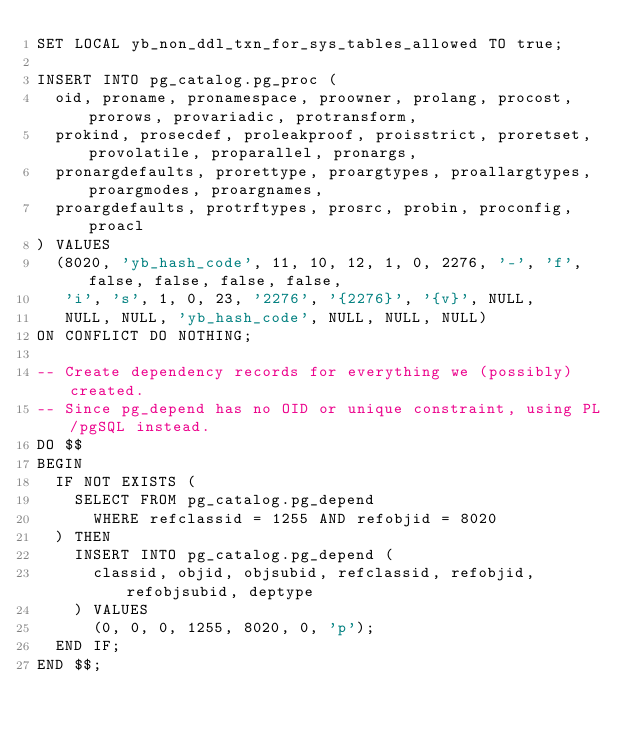<code> <loc_0><loc_0><loc_500><loc_500><_SQL_>SET LOCAL yb_non_ddl_txn_for_sys_tables_allowed TO true;

INSERT INTO pg_catalog.pg_proc (
  oid, proname, pronamespace, proowner, prolang, procost, prorows, provariadic, protransform,
  prokind, prosecdef, proleakproof, proisstrict, proretset, provolatile, proparallel, pronargs,
  pronargdefaults, prorettype, proargtypes, proallargtypes, proargmodes, proargnames,
  proargdefaults, protrftypes, prosrc, probin, proconfig, proacl
) VALUES
  (8020, 'yb_hash_code', 11, 10, 12, 1, 0, 2276, '-', 'f', false, false, false, false,
   'i', 's', 1, 0, 23, '2276', '{2276}', '{v}', NULL,
   NULL, NULL, 'yb_hash_code', NULL, NULL, NULL)
ON CONFLICT DO NOTHING;

-- Create dependency records for everything we (possibly) created.
-- Since pg_depend has no OID or unique constraint, using PL/pgSQL instead.
DO $$
BEGIN
  IF NOT EXISTS (
    SELECT FROM pg_catalog.pg_depend
      WHERE refclassid = 1255 AND refobjid = 8020
  ) THEN
    INSERT INTO pg_catalog.pg_depend (
      classid, objid, objsubid, refclassid, refobjid, refobjsubid, deptype
    ) VALUES
      (0, 0, 0, 1255, 8020, 0, 'p');
  END IF;
END $$;
</code> 